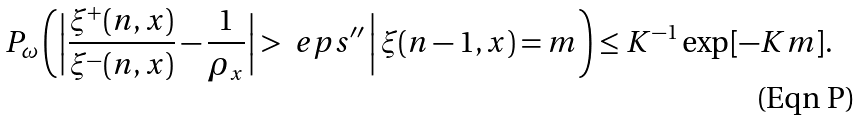Convert formula to latex. <formula><loc_0><loc_0><loc_500><loc_500>P _ { \omega } \left ( \Big | \frac { \xi ^ { + } ( n , x ) } { \xi ^ { - } ( n , x ) } - \frac { 1 } { \rho _ { x } } \Big | > \ e p s ^ { \prime \prime } \, \Big | \, \xi ( n - 1 , x ) = m \right ) \leq K ^ { - 1 } \exp [ - K m ] .</formula> 